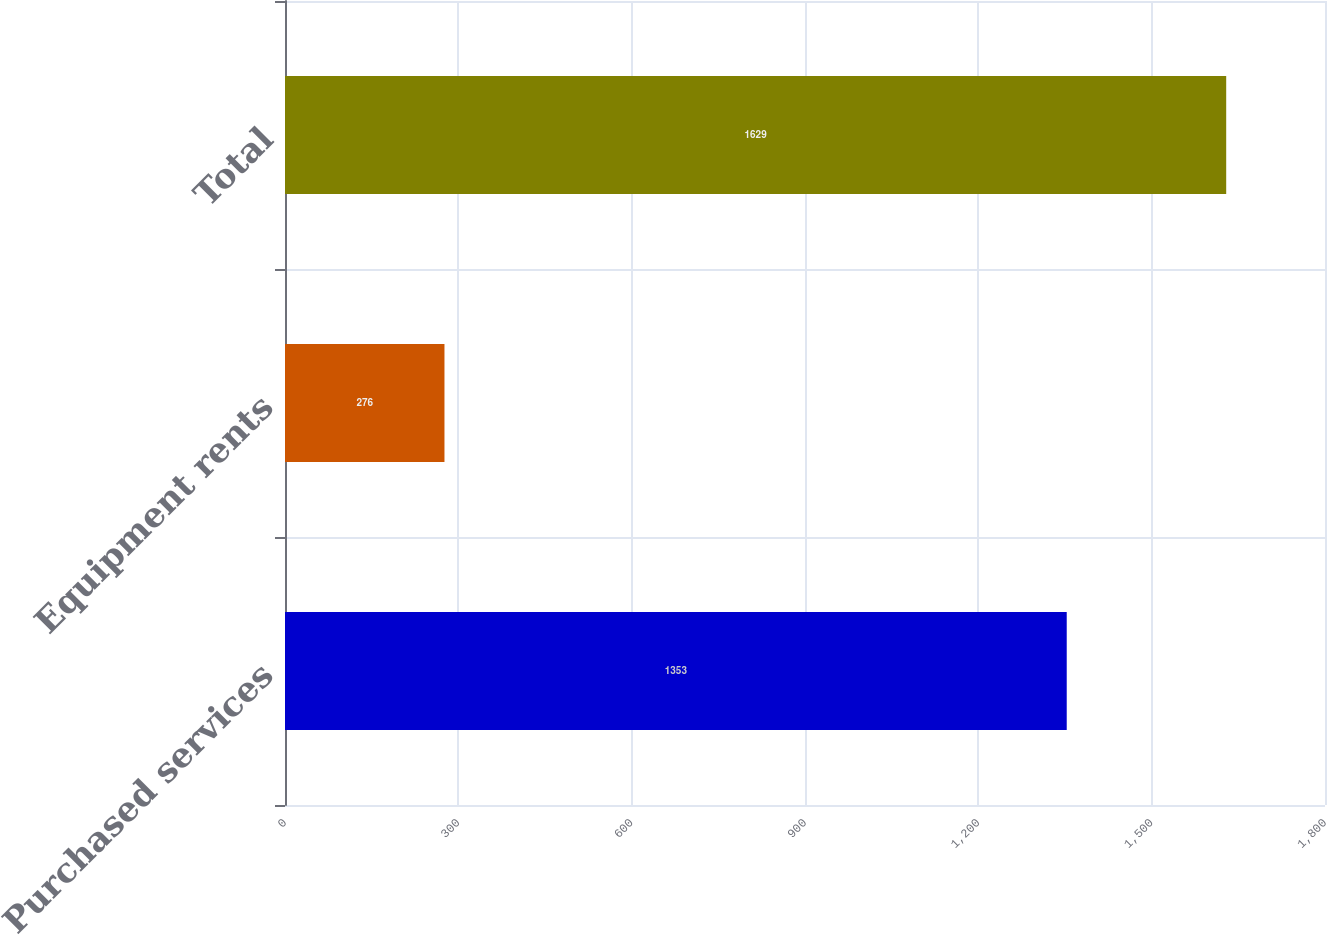<chart> <loc_0><loc_0><loc_500><loc_500><bar_chart><fcel>Purchased services<fcel>Equipment rents<fcel>Total<nl><fcel>1353<fcel>276<fcel>1629<nl></chart> 